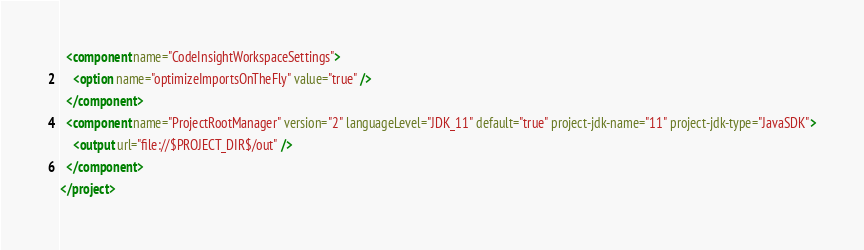<code> <loc_0><loc_0><loc_500><loc_500><_XML_>  <component name="CodeInsightWorkspaceSettings">
    <option name="optimizeImportsOnTheFly" value="true" />
  </component>
  <component name="ProjectRootManager" version="2" languageLevel="JDK_11" default="true" project-jdk-name="11" project-jdk-type="JavaSDK">
    <output url="file://$PROJECT_DIR$/out" />
  </component>
</project></code> 